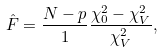<formula> <loc_0><loc_0><loc_500><loc_500>\hat { F } = \frac { N - p } { 1 } \frac { \chi ^ { 2 } _ { 0 } - \chi ^ { 2 } _ { V } } { \chi ^ { 2 } _ { V } } ,</formula> 